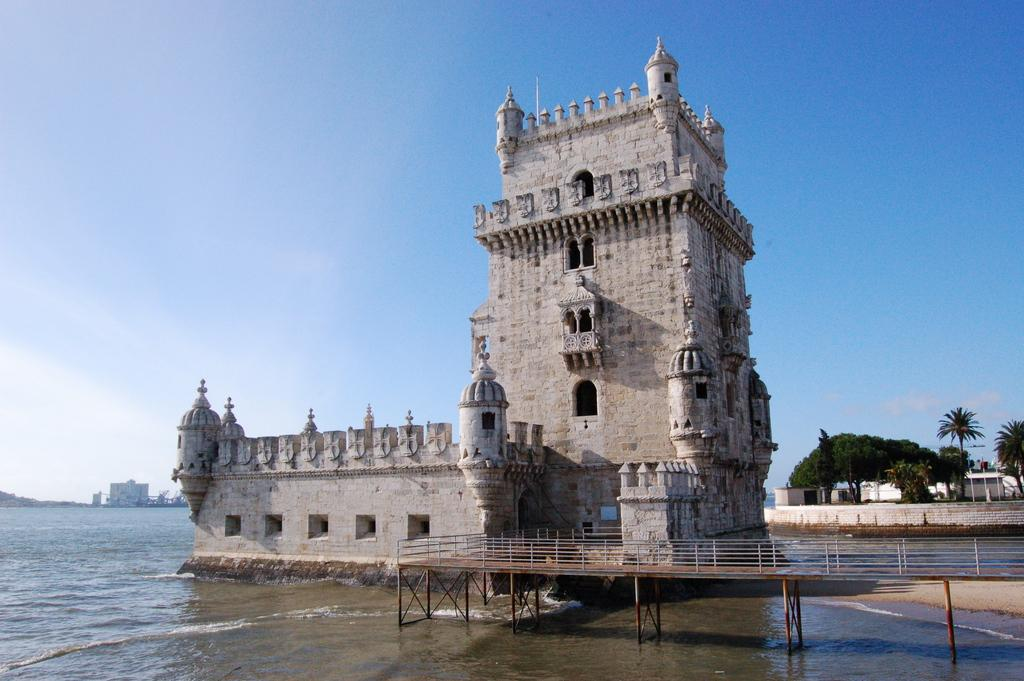What is present in the image that is not solid? There is water in the image. What structure can be seen in the image? There is a platform in the image. What type of man-made structures are visible in the image? There are buildings in the image. What type of vegetation is on the right side of the image? There are trees on the right side of the image. What can be seen in the sky in the background of the image? There are clouds in the background of the image. What is visible in the sky in the background of the image? The sky is visible in the background of the image. Where is the uncle standing in the image? There is no uncle present in the image. What type of stone is used to make the pies in the image? There are no pies present in the image. 